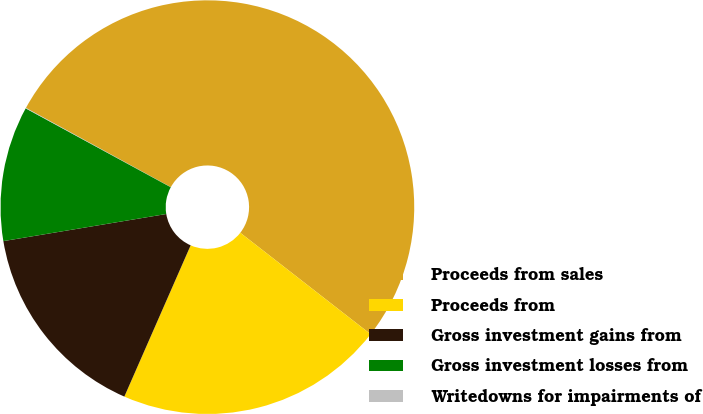<chart> <loc_0><loc_0><loc_500><loc_500><pie_chart><fcel>Proceeds from sales<fcel>Proceeds from<fcel>Gross investment gains from<fcel>Gross investment losses from<fcel>Writedowns for impairments of<nl><fcel>52.56%<fcel>21.05%<fcel>15.8%<fcel>10.55%<fcel>0.04%<nl></chart> 